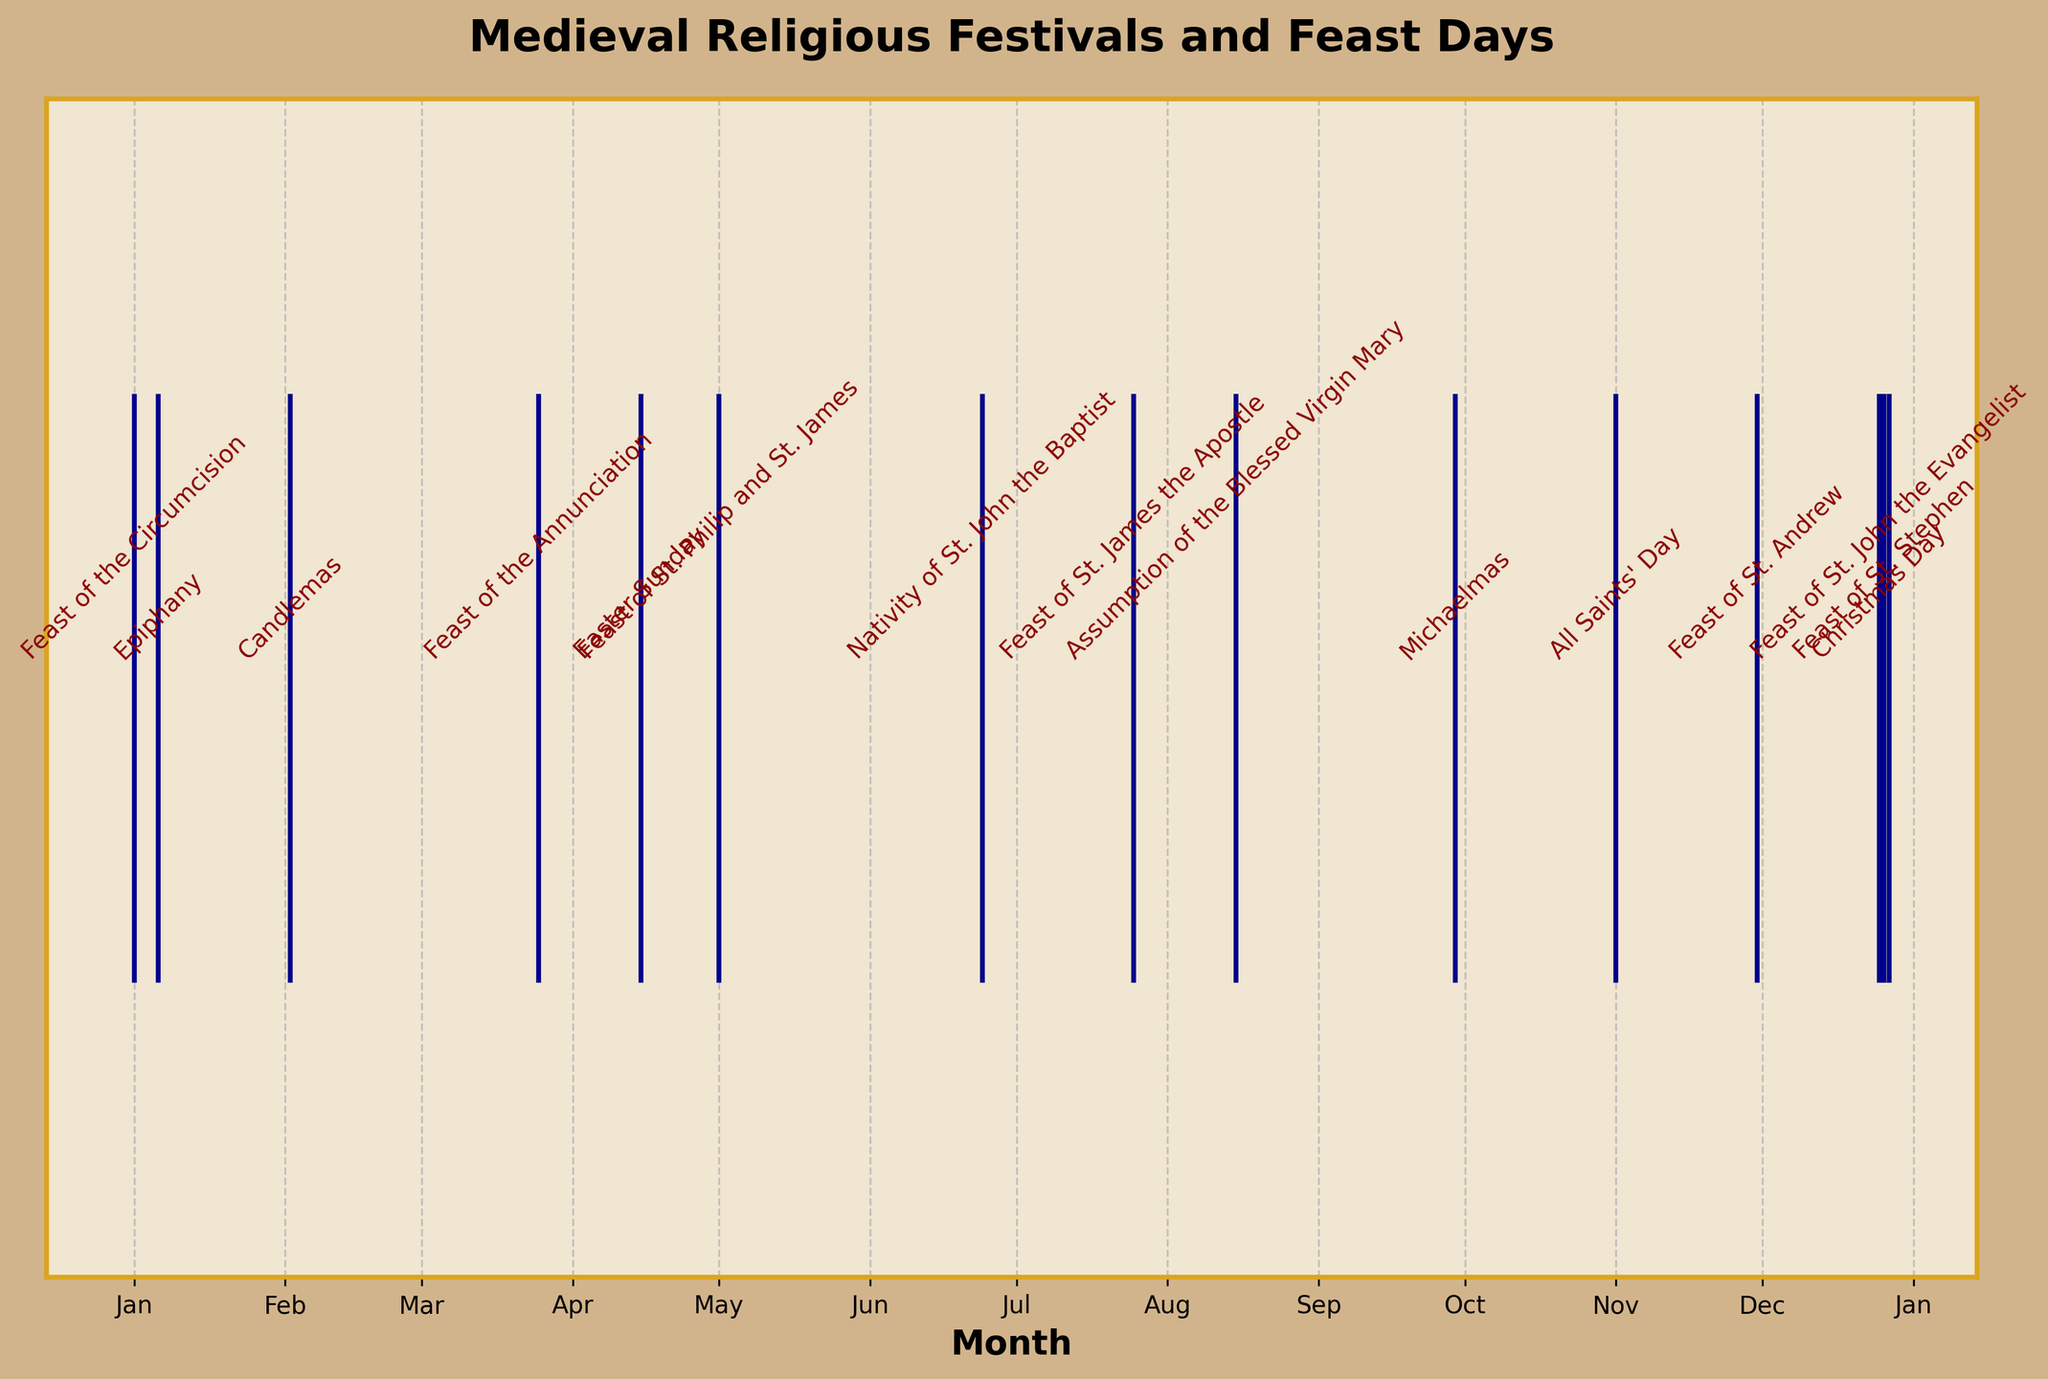What is the title of the plot? The title is located at the top of the plot, and it clearly states "Medieval Religious Festivals and Feast Days".
Answer: Medieval Religious Festivals and Feast Days What does the y-axis represent, and what are its ticks? The y-axis doesn't have any specific label or ticks, likely indicating that the y-axis is not used to convey specific information in this plot.
Answer: Unlabeled, no ticks How many religious festivals and feast days are plotted? The number of events can be counted from the annotations along the event line. In the plot, there are 14 annotated festivals and feast days.
Answer: 14 Which month has the highest concentration of religious festivals and feast days? Observing the annotations, December has the highest concentration with 3 events (Christmas Day, Feast of St. Stephen, Feast of St. John the Evangelist).
Answer: December What is the distribution of events across the months with the least number of festivals? By counting the annotations for each month visually, there are multiple months (February, March, April, July, August, and November) each containing only one event.
Answer: 6 months with one festival each How many festivals occur in the first quarter of the year (January to March)? The first quarter has events on January 1, January 6, February 2, and March 25, giving a total of 4 events.
Answer: 4 Which festival occurs the latest in the calendar year? Checking the annotations and dates, the latest festival in the year is on December 27, which is the Feast of St. John the Evangelist.
Answer: Feast of St. John the Evangelist How many festivals occur during the summer months (June to August)? The events can be visually identified in June, July, and August. There are festivals on June 24, July 25, and August 15, making the total 3.
Answer: 3 Which event occurs right after Michaelmas? Michaelmas is on September 29. The next event on the visual plot is All Saints' Day on November 1.
Answer: All Saints' Day Which is the earliest festival in the medieval calendar year? As observed from the annotations, the earliest festival is the Feast of the Circumcision on January 1.
Answer: Feast of the Circumcision 